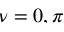<formula> <loc_0><loc_0><loc_500><loc_500>\nu = 0 , \pi</formula> 